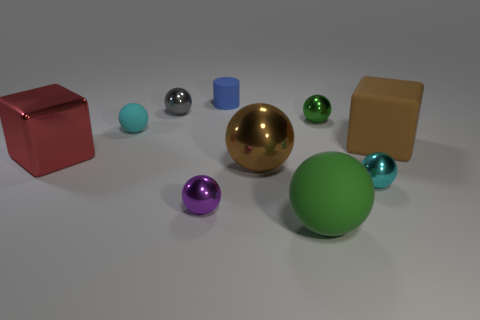Subtract all small cyan spheres. How many spheres are left? 5 Subtract all brown balls. How many balls are left? 6 Subtract all blue spheres. Subtract all gray cubes. How many spheres are left? 7 Subtract all cylinders. How many objects are left? 9 Subtract all small blue things. Subtract all purple metal things. How many objects are left? 8 Add 2 tiny cyan balls. How many tiny cyan balls are left? 4 Add 5 blue things. How many blue things exist? 6 Subtract 1 blue cylinders. How many objects are left? 9 